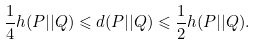Convert formula to latex. <formula><loc_0><loc_0><loc_500><loc_500>\frac { 1 } { 4 } h ( P | | Q ) \leqslant d ( P | | Q ) \leqslant \frac { 1 } { 2 } h ( P | | Q ) .</formula> 